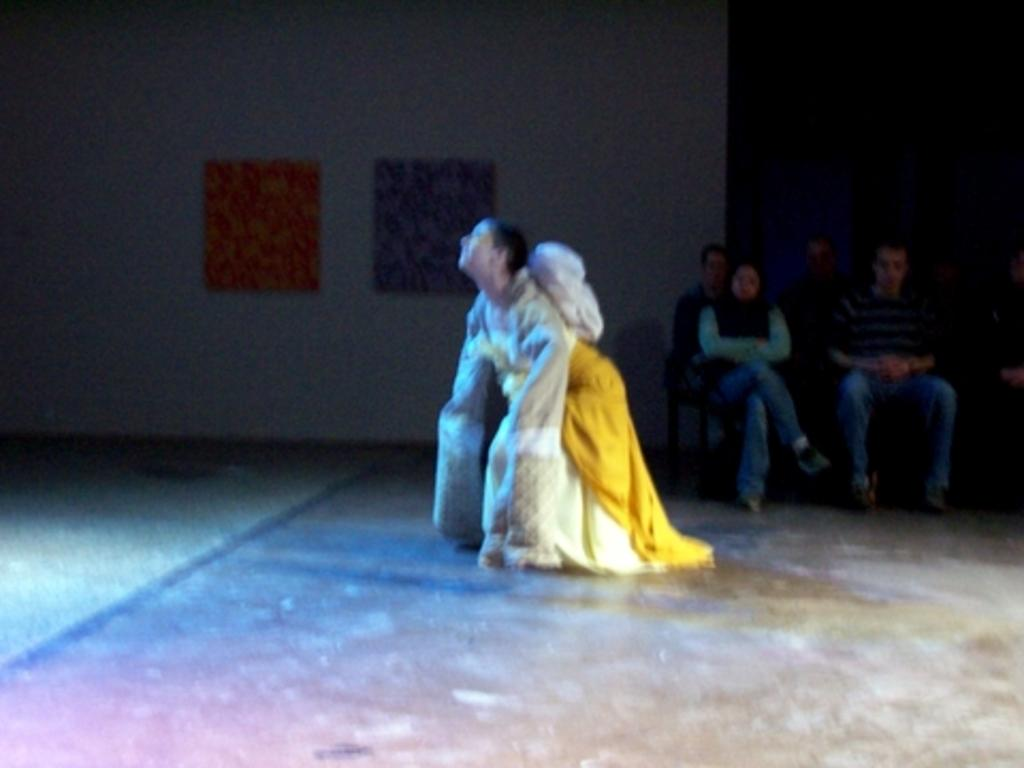What is the main subject of the image? There is a person in the image. Can you describe the person's attire? The person is wearing a yellow and white color dress. What can be seen in the background of the image? There are people sitting on chairs in the background. What color is the wall in the background? The wall in the background is white. How does the wind affect the person's dress in the image? There is no indication of wind in the image, so we cannot determine its effect on the person's dress. Is there a pocket visible on the person's dress in the image? The provided facts do not mention any pockets on the dress, so we cannot determine if there is a pocket present. 